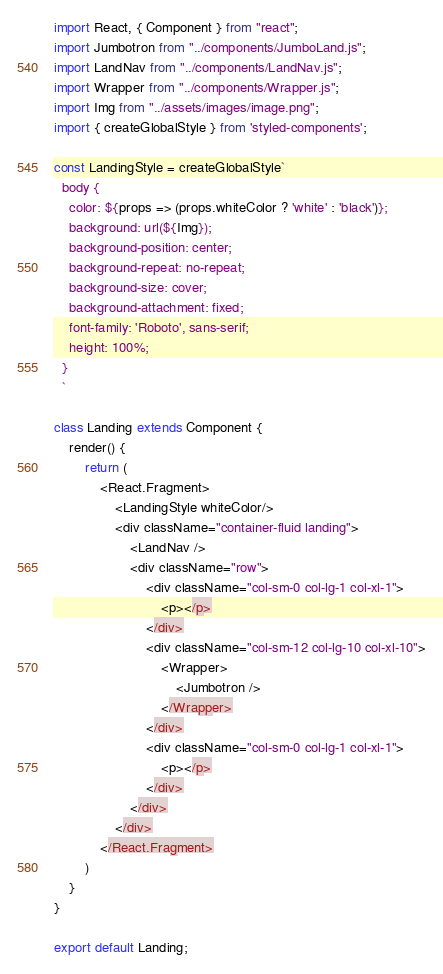Convert code to text. <code><loc_0><loc_0><loc_500><loc_500><_JavaScript_>import React, { Component } from "react";
import Jumbotron from "../components/JumboLand.js";
import LandNav from "../components/LandNav.js";
import Wrapper from "../components/Wrapper.js";
import Img from "../assets/images/image.png";
import { createGlobalStyle } from 'styled-components';

const LandingStyle = createGlobalStyle`
  body {
    color: ${props => (props.whiteColor ? 'white' : 'black')};
    background: url(${Img});
    background-position: center;
    background-repeat: no-repeat;
    background-size: cover;
    background-attachment: fixed;
    font-family: 'Roboto', sans-serif;
    height: 100%;
  }
  `

class Landing extends Component {
    render() {
        return (
            <React.Fragment>
                <LandingStyle whiteColor/>
                <div className="container-fluid landing">
                    <LandNav />
                    <div className="row">
                        <div className="col-sm-0 col-lg-1 col-xl-1">
                            <p></p>
                        </div>
                        <div className="col-sm-12 col-lg-10 col-xl-10">
                            <Wrapper>
                                <Jumbotron />
                            </Wrapper>
                        </div>
                        <div className="col-sm-0 col-lg-1 col-xl-1">
                            <p></p>
                        </div>
                    </div>
                </div>
            </React.Fragment>
        )
    }
}

export default Landing;

</code> 